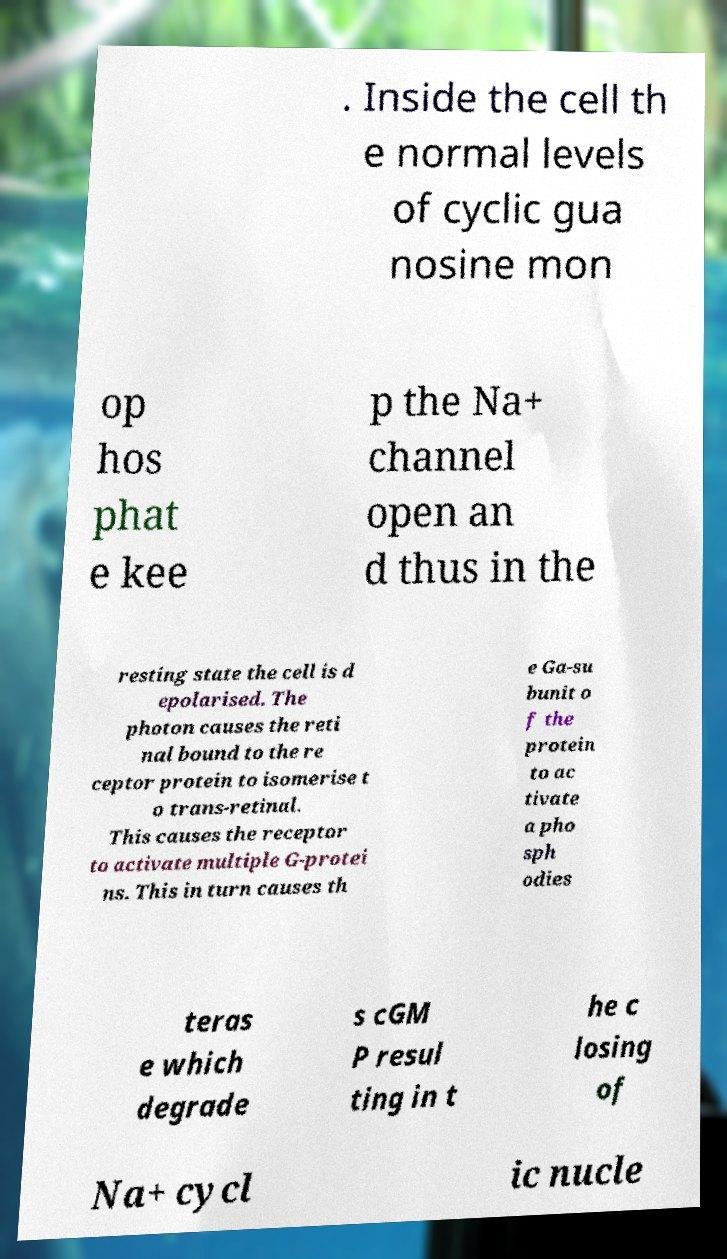I need the written content from this picture converted into text. Can you do that? . Inside the cell th e normal levels of cyclic gua nosine mon op hos phat e kee p the Na+ channel open an d thus in the resting state the cell is d epolarised. The photon causes the reti nal bound to the re ceptor protein to isomerise t o trans-retinal. This causes the receptor to activate multiple G-protei ns. This in turn causes th e Ga-su bunit o f the protein to ac tivate a pho sph odies teras e which degrade s cGM P resul ting in t he c losing of Na+ cycl ic nucle 